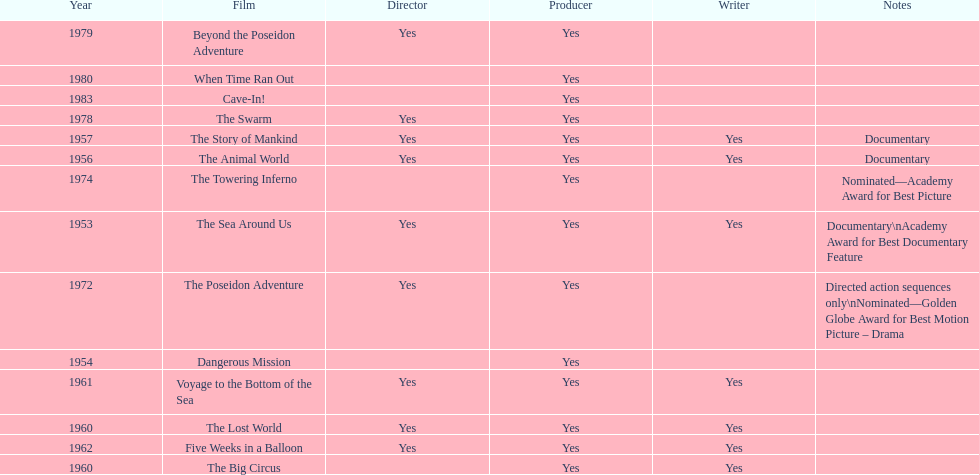How many films did irwin allen direct, produce and write? 6. 